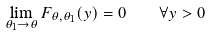Convert formula to latex. <formula><loc_0><loc_0><loc_500><loc_500>\lim _ { \theta _ { 1 } \to \theta } F _ { \theta , \theta _ { 1 } } ( y ) = 0 \quad \forall y > 0</formula> 